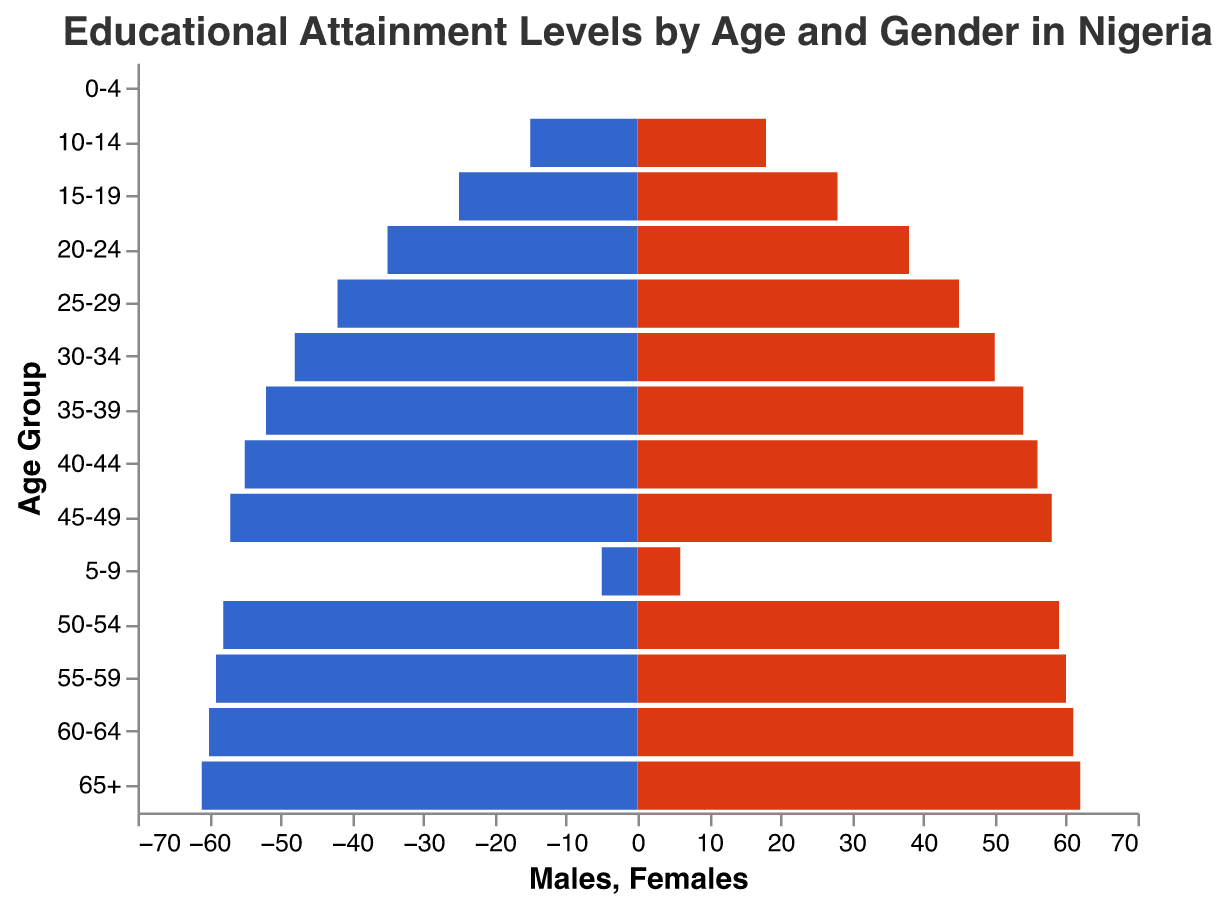What's the title of the figure? The title of the figure is typically located at the top of the chart and often describes what the chart is about. In this case, the title is "Educational Attainment Levels by Age and Gender in Nigeria."
Answer: Educational Attainment Levels by Age and Gender in Nigeria Which age group has the highest number of females? By looking at the height of the bars on the females' side, the group with the highest bar is the age group "65+", which has 62 females.
Answer: 65+ What is the difference in the number of males and females in the 25-29 age group? From the data, there are 42 males and 45 females in the 25-29 age group. The difference is calculated as 45 - 42.
Answer: 3 How many total individuals are there in the 40-44 age group? The number of males in the 40-44 age group is 55 and females are 56. The total is the sum of both, calculated as 55 + 56.
Answer: 111 Is there any age group where the number of males and females is equal? Each age group's bar heights should be compared. All age groups have different bar heights for males and females. Thus, there is no age group with equal numbers of males and females.
Answer: No What trends can you observe in educational attainment between males and females as age increases? By observing the length of the bars from the youngest to the oldest age groups, both the male and female educational attainment increases initially. However, the educational attainment is slightly higher for females in each age group.
Answer: Educational attainment increases with age, and females consistently have slightly higher attainment than males In which age groups are females significantly outnumbering males? Significant differences can be noted by comparing the lengths of the bars. Females consistently outnumber males across the age groups, but the differences are notably larger in the younger age groups such as 10-14 and 15-19.
Answer: 10-14, 15-19 How does the number of males change from the 20-24 age group to the 30-34 age group? By comparing the number of males between the 20-24 age group (35) and the 30-34 age group (48), the difference is calculated as 48 - 35.
Answer: Increases by 13 Which age group has the smallest difference in educational attainment between males and females? By comparing the differences between males' and females' numbers in each age group visually or using the data, the smallest difference is in the younger age group, such as 60-64 (61 - 60 = 1).
Answer: 60-64 Overall, do more males or females have higher educational attainment levels across all age groups? Sum the totals of males and females across all age groups and compare the sums. Total males sum is 512, and the total for females is 545, indicating females have higher educational attainment overall.
Answer: Females 